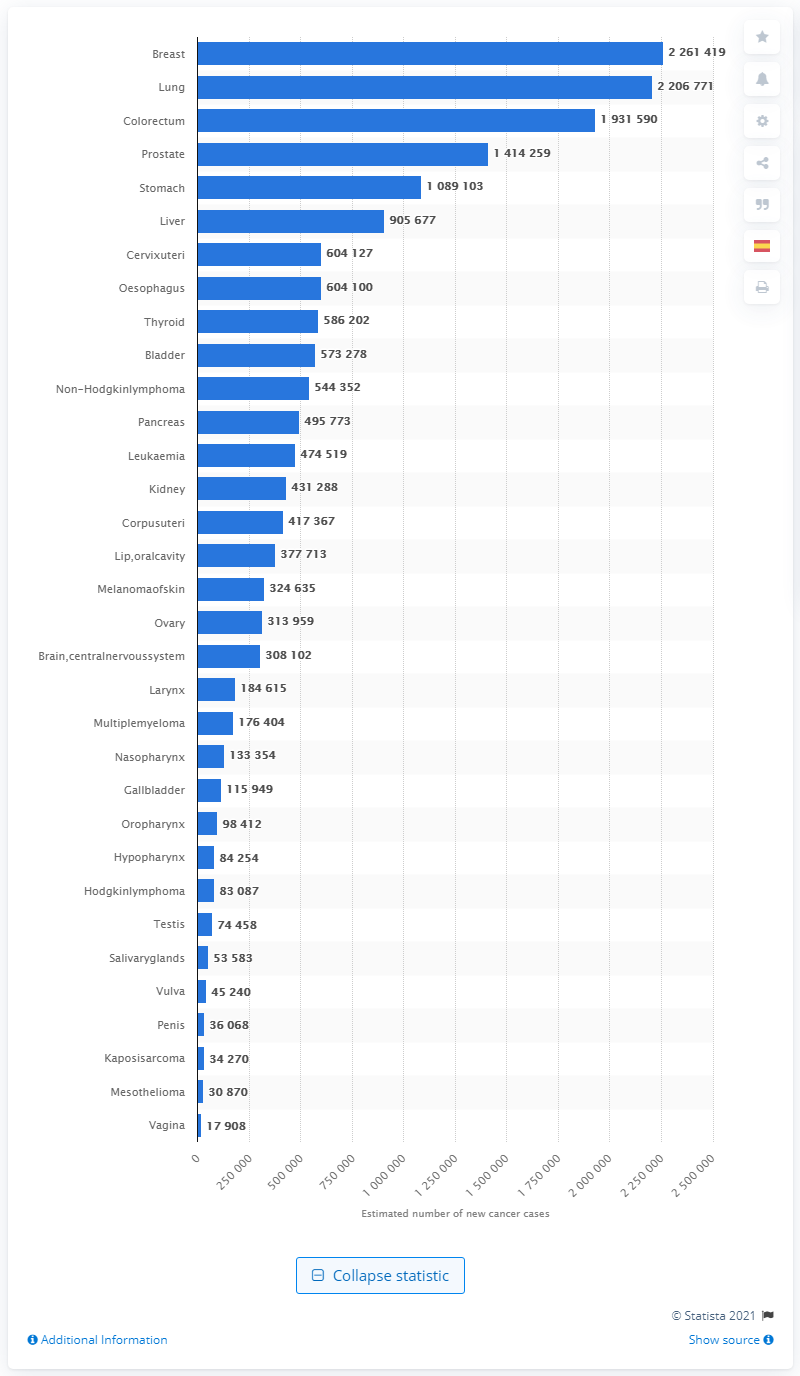Indicate a few pertinent items in this graphic. In the year 2020, there were approximately 220,6771 new cases of cancer diagnosed. 